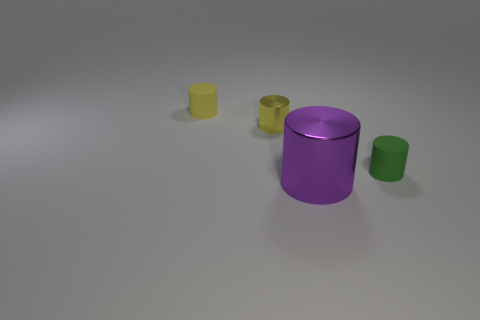Subtract 1 cylinders. How many cylinders are left? 3 Add 4 metallic things. How many objects exist? 8 Subtract all tiny yellow things. Subtract all big cylinders. How many objects are left? 1 Add 4 small green objects. How many small green objects are left? 5 Add 2 tiny cylinders. How many tiny cylinders exist? 5 Subtract 0 cyan spheres. How many objects are left? 4 